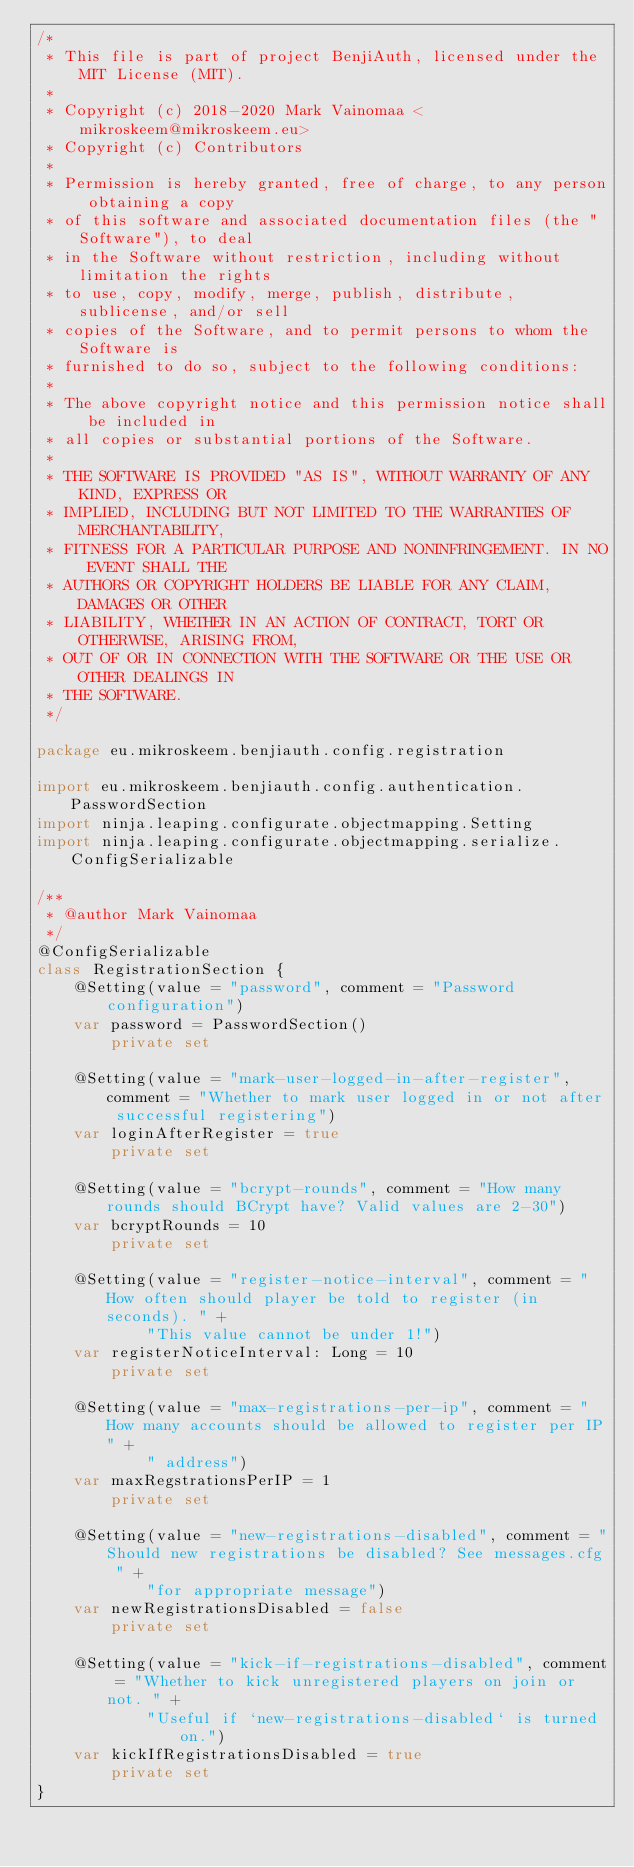Convert code to text. <code><loc_0><loc_0><loc_500><loc_500><_Kotlin_>/*
 * This file is part of project BenjiAuth, licensed under the MIT License (MIT).
 *
 * Copyright (c) 2018-2020 Mark Vainomaa <mikroskeem@mikroskeem.eu>
 * Copyright (c) Contributors
 *
 * Permission is hereby granted, free of charge, to any person obtaining a copy
 * of this software and associated documentation files (the "Software"), to deal
 * in the Software without restriction, including without limitation the rights
 * to use, copy, modify, merge, publish, distribute, sublicense, and/or sell
 * copies of the Software, and to permit persons to whom the Software is
 * furnished to do so, subject to the following conditions:
 *
 * The above copyright notice and this permission notice shall be included in
 * all copies or substantial portions of the Software.
 *
 * THE SOFTWARE IS PROVIDED "AS IS", WITHOUT WARRANTY OF ANY KIND, EXPRESS OR
 * IMPLIED, INCLUDING BUT NOT LIMITED TO THE WARRANTIES OF MERCHANTABILITY,
 * FITNESS FOR A PARTICULAR PURPOSE AND NONINFRINGEMENT. IN NO EVENT SHALL THE
 * AUTHORS OR COPYRIGHT HOLDERS BE LIABLE FOR ANY CLAIM, DAMAGES OR OTHER
 * LIABILITY, WHETHER IN AN ACTION OF CONTRACT, TORT OR OTHERWISE, ARISING FROM,
 * OUT OF OR IN CONNECTION WITH THE SOFTWARE OR THE USE OR OTHER DEALINGS IN
 * THE SOFTWARE.
 */

package eu.mikroskeem.benjiauth.config.registration

import eu.mikroskeem.benjiauth.config.authentication.PasswordSection
import ninja.leaping.configurate.objectmapping.Setting
import ninja.leaping.configurate.objectmapping.serialize.ConfigSerializable

/**
 * @author Mark Vainomaa
 */
@ConfigSerializable
class RegistrationSection {
    @Setting(value = "password", comment = "Password configuration")
    var password = PasswordSection()
        private set

    @Setting(value = "mark-user-logged-in-after-register", comment = "Whether to mark user logged in or not after successful registering")
    var loginAfterRegister = true
        private set

    @Setting(value = "bcrypt-rounds", comment = "How many rounds should BCrypt have? Valid values are 2-30")
    var bcryptRounds = 10
        private set

    @Setting(value = "register-notice-interval", comment = "How often should player be told to register (in seconds). " +
            "This value cannot be under 1!")
    var registerNoticeInterval: Long = 10
        private set

    @Setting(value = "max-registrations-per-ip", comment = "How many accounts should be allowed to register per IP" +
            " address")
    var maxRegstrationsPerIP = 1
        private set

    @Setting(value = "new-registrations-disabled", comment = "Should new registrations be disabled? See messages.cfg " +
            "for appropriate message")
    var newRegistrationsDisabled = false
        private set

    @Setting(value = "kick-if-registrations-disabled", comment = "Whether to kick unregistered players on join or not. " +
            "Useful if `new-registrations-disabled` is turned on.")
    var kickIfRegistrationsDisabled = true
        private set
}</code> 